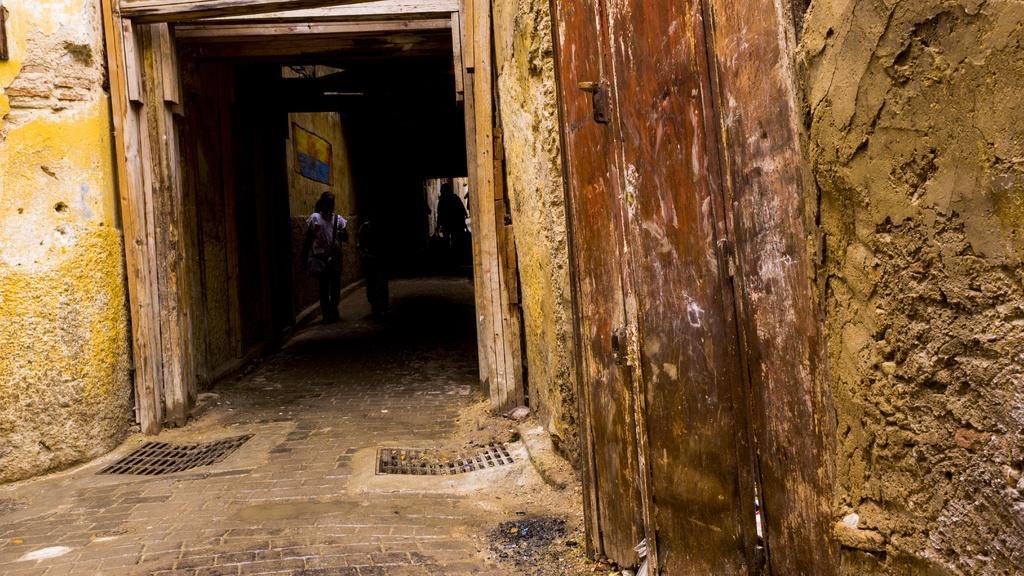How would you summarize this image in a sentence or two? In this image I can see few people are standing. I can also see little bit darkness over there. 